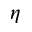<formula> <loc_0><loc_0><loc_500><loc_500>\eta</formula> 